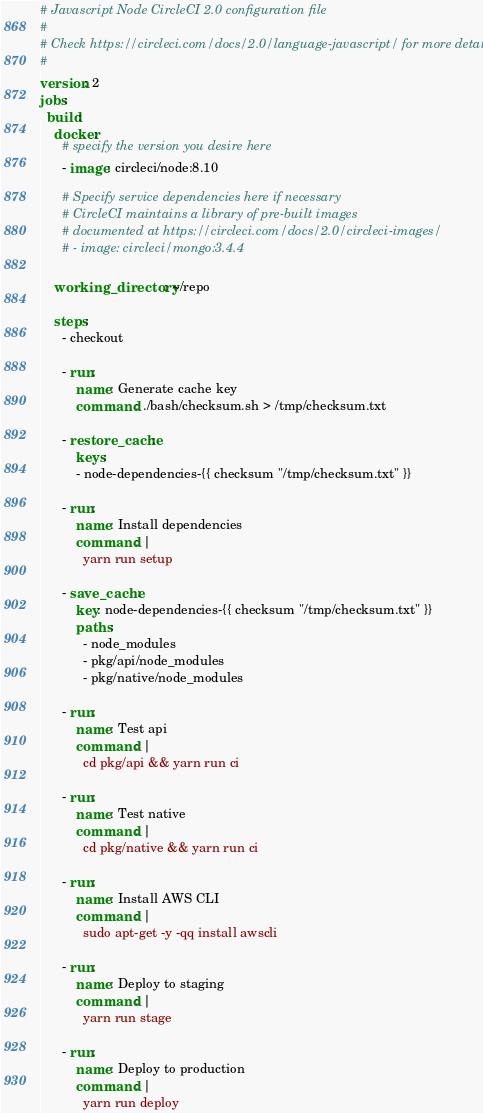<code> <loc_0><loc_0><loc_500><loc_500><_YAML_># Javascript Node CircleCI 2.0 configuration file
#
# Check https://circleci.com/docs/2.0/language-javascript/ for more details
#
version: 2
jobs:
  build:
    docker:
      # specify the version you desire here
      - image: circleci/node:8.10

      # Specify service dependencies here if necessary
      # CircleCI maintains a library of pre-built images
      # documented at https://circleci.com/docs/2.0/circleci-images/
      # - image: circleci/mongo:3.4.4

    working_directory: ~/repo

    steps:
      - checkout

      - run:
          name: Generate cache key
          command: ./bash/checksum.sh > /tmp/checksum.txt

      - restore_cache:
          keys:
          - node-dependencies-{{ checksum "/tmp/checksum.txt" }}

      - run:
          name: Install dependencies
          command: |
            yarn run setup

      - save_cache:
          key: node-dependencies-{{ checksum "/tmp/checksum.txt" }}
          paths:
            - node_modules
            - pkg/api/node_modules
            - pkg/native/node_modules

      - run:
          name: Test api
          command: |
            cd pkg/api && yarn run ci

      - run:
          name: Test native
          command: |
            cd pkg/native && yarn run ci

      - run:
          name: Install AWS CLI
          command: |
            sudo apt-get -y -qq install awscli

      - run:
          name: Deploy to staging
          command: |
            yarn run stage

      - run:
          name: Deploy to production
          command: |
            yarn run deploy
</code> 